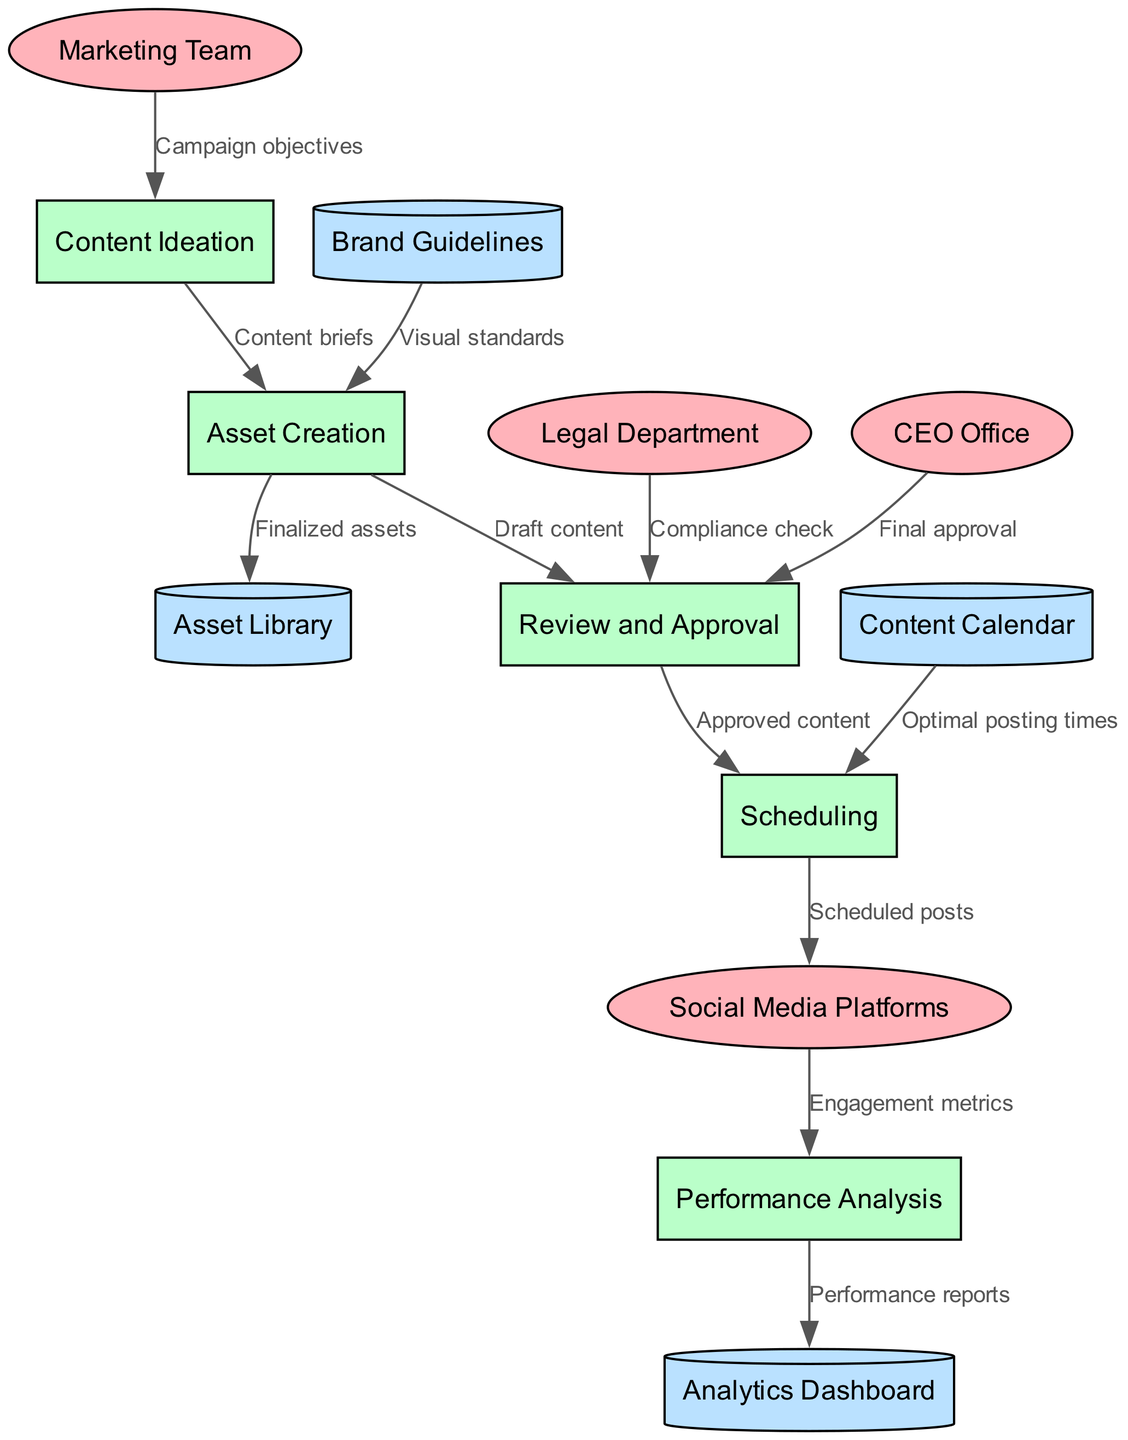What is the first process in the workflow? The diagram shows "Content Ideation" as the first process where the marketing team provides campaign objectives.
Answer: Content Ideation How many external entities are present? The diagram lists four external entities: Marketing Team, Legal Department, CEO Office, and Social Media Platforms.
Answer: 4 Which process receives "Draft content"? The diagram indicates that "Draft content" flows from Asset Creation to the "Review and Approval" process.
Answer: Review and Approval What type of data store is "Analytics Dashboard"? The diagram categorizes "Analytics Dashboard" as a cylinder, which indicates it is a data store in the workflow.
Answer: Data Store What does the Legal Department provide to the "Review and Approval" process? According to the diagram, the Legal Department provides a "Compliance check" to the "Review and Approval" process.
Answer: Compliance check Which process uses the "Content Calendar"? The diagram shows that "Content Calendar" feeds into the "Scheduling" process, indicating it is used there.
Answer: Scheduling What is the final step of the workflow? The flow diagram shows that the last process is "Performance Analysis" which occurs after "Scheduled posts" have been sent to "Social Media Platforms".
Answer: Performance Analysis How many data flows are present in the diagram? By counting the data flows visually in the diagram, there are a total of 11 flows connecting various processes, entities, and data stores.
Answer: 11 What entities are involved in the final approval? The diagram identifies the CEO Office as the external entity involved in the "Final approval" part of the "Review and Approval" process.
Answer: CEO Office 